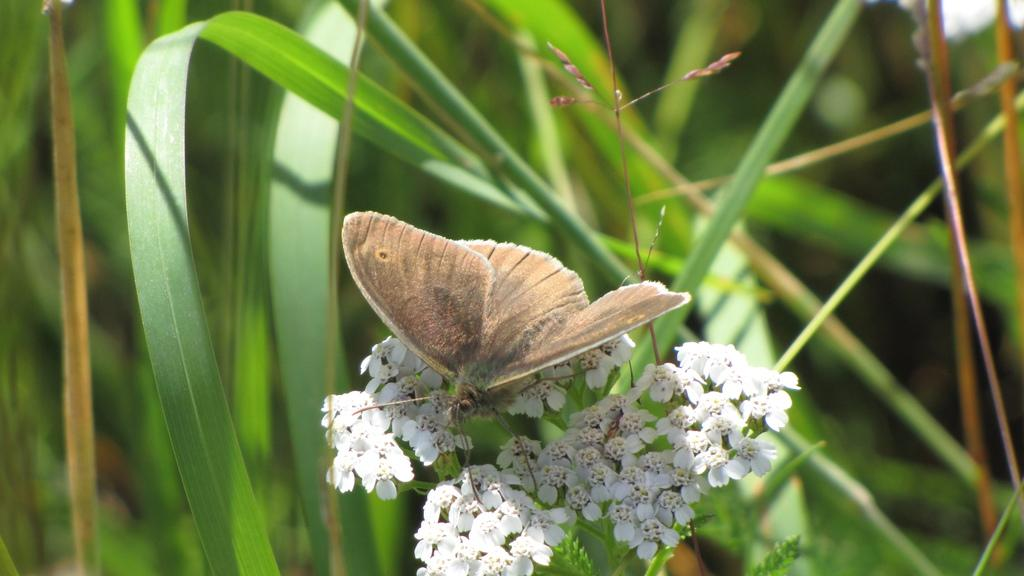What is the main subject of the image? There is a butterfly in the image. Where is the butterfly located? The butterfly is on flowers. What else can be seen in the image besides the butterfly? There are plants visible in the image. Can you describe the background of the image? The background of the image is blurred. How many stones can be seen in the image? There are no stones present in the image. What type of boats are visible in the image? There are no boats present in the image. 